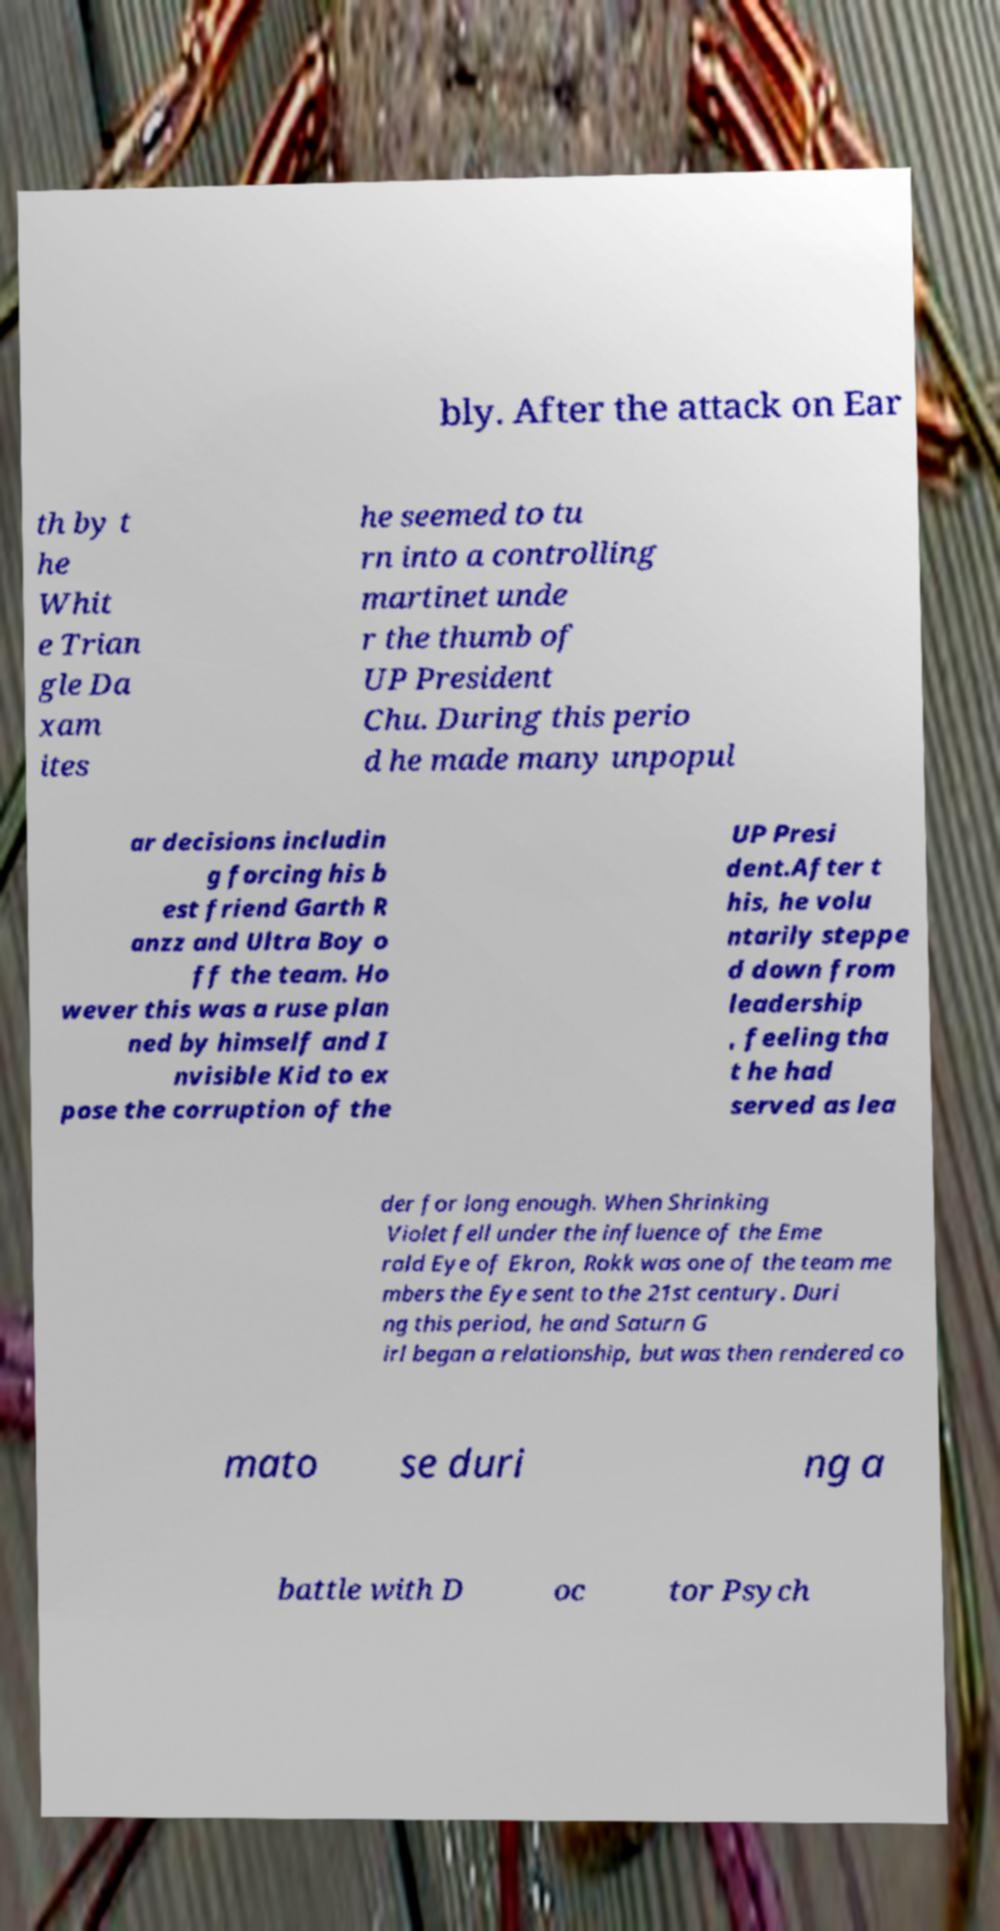There's text embedded in this image that I need extracted. Can you transcribe it verbatim? bly. After the attack on Ear th by t he Whit e Trian gle Da xam ites he seemed to tu rn into a controlling martinet unde r the thumb of UP President Chu. During this perio d he made many unpopul ar decisions includin g forcing his b est friend Garth R anzz and Ultra Boy o ff the team. Ho wever this was a ruse plan ned by himself and I nvisible Kid to ex pose the corruption of the UP Presi dent.After t his, he volu ntarily steppe d down from leadership , feeling tha t he had served as lea der for long enough. When Shrinking Violet fell under the influence of the Eme rald Eye of Ekron, Rokk was one of the team me mbers the Eye sent to the 21st century. Duri ng this period, he and Saturn G irl began a relationship, but was then rendered co mato se duri ng a battle with D oc tor Psych 